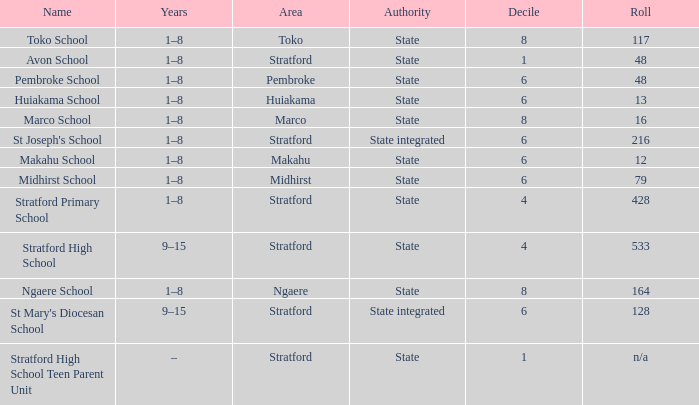What is the lowest decile with a state authority and Midhirst school? 6.0. 